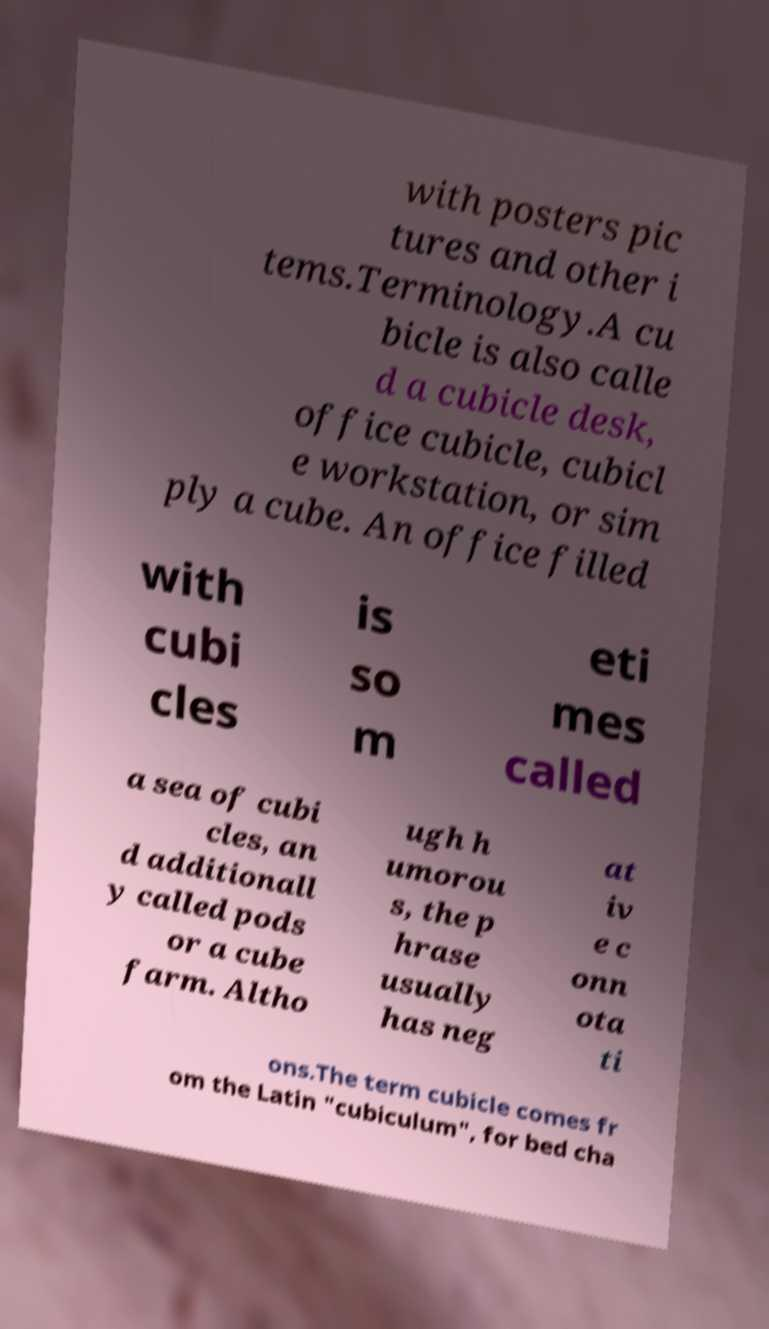There's text embedded in this image that I need extracted. Can you transcribe it verbatim? with posters pic tures and other i tems.Terminology.A cu bicle is also calle d a cubicle desk, office cubicle, cubicl e workstation, or sim ply a cube. An office filled with cubi cles is so m eti mes called a sea of cubi cles, an d additionall y called pods or a cube farm. Altho ugh h umorou s, the p hrase usually has neg at iv e c onn ota ti ons.The term cubicle comes fr om the Latin "cubiculum", for bed cha 